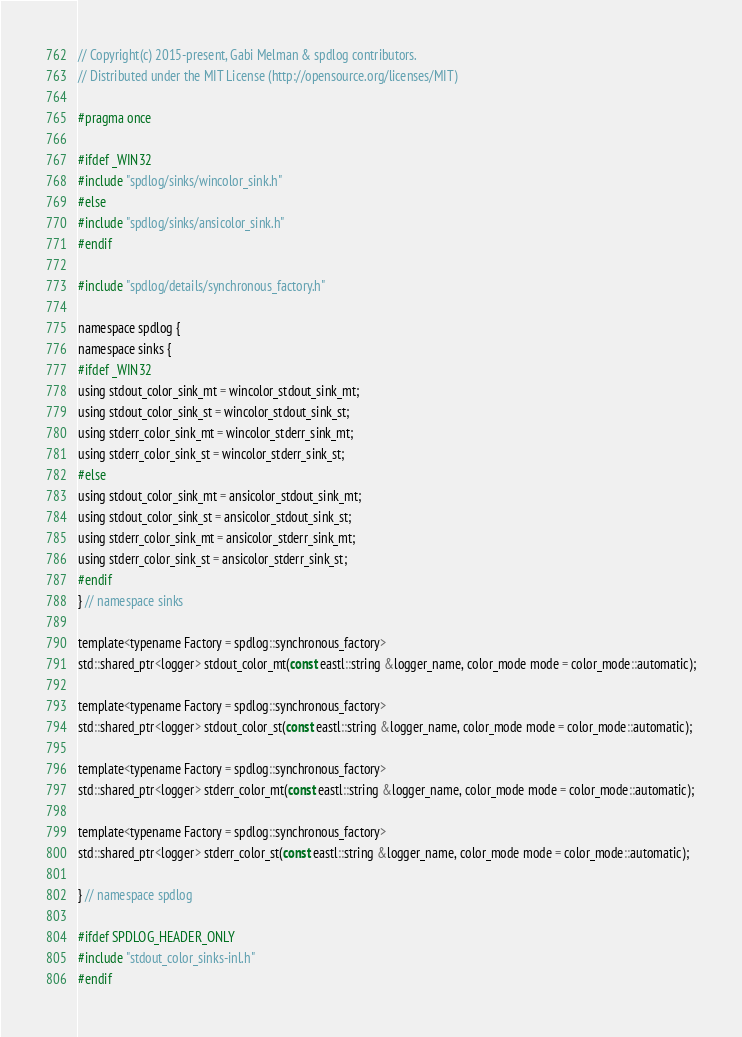Convert code to text. <code><loc_0><loc_0><loc_500><loc_500><_C_>// Copyright(c) 2015-present, Gabi Melman & spdlog contributors.
// Distributed under the MIT License (http://opensource.org/licenses/MIT)

#pragma once

#ifdef _WIN32
#include "spdlog/sinks/wincolor_sink.h"
#else
#include "spdlog/sinks/ansicolor_sink.h"
#endif

#include "spdlog/details/synchronous_factory.h"

namespace spdlog {
namespace sinks {
#ifdef _WIN32
using stdout_color_sink_mt = wincolor_stdout_sink_mt;
using stdout_color_sink_st = wincolor_stdout_sink_st;
using stderr_color_sink_mt = wincolor_stderr_sink_mt;
using stderr_color_sink_st = wincolor_stderr_sink_st;
#else
using stdout_color_sink_mt = ansicolor_stdout_sink_mt;
using stdout_color_sink_st = ansicolor_stdout_sink_st;
using stderr_color_sink_mt = ansicolor_stderr_sink_mt;
using stderr_color_sink_st = ansicolor_stderr_sink_st;
#endif
} // namespace sinks

template<typename Factory = spdlog::synchronous_factory>
std::shared_ptr<logger> stdout_color_mt(const eastl::string &logger_name, color_mode mode = color_mode::automatic);

template<typename Factory = spdlog::synchronous_factory>
std::shared_ptr<logger> stdout_color_st(const eastl::string &logger_name, color_mode mode = color_mode::automatic);

template<typename Factory = spdlog::synchronous_factory>
std::shared_ptr<logger> stderr_color_mt(const eastl::string &logger_name, color_mode mode = color_mode::automatic);

template<typename Factory = spdlog::synchronous_factory>
std::shared_ptr<logger> stderr_color_st(const eastl::string &logger_name, color_mode mode = color_mode::automatic);

} // namespace spdlog

#ifdef SPDLOG_HEADER_ONLY
#include "stdout_color_sinks-inl.h"
#endif
</code> 